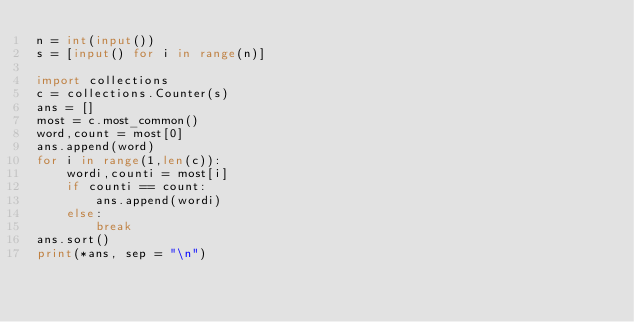Convert code to text. <code><loc_0><loc_0><loc_500><loc_500><_Python_>n = int(input())
s = [input() for i in range(n)]

import collections
c = collections.Counter(s)
ans = []
most = c.most_common()
word,count = most[0]
ans.append(word)
for i in range(1,len(c)):
    wordi,counti = most[i]
    if counti == count:
        ans.append(wordi)
    else:
        break
ans.sort()
print(*ans, sep = "\n")</code> 